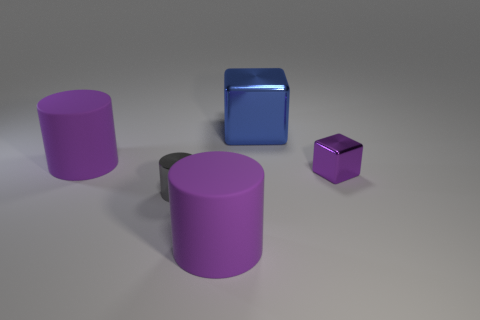Can you estimate the sizes of the objects relative to each other? Starting with the largest object, the tall aubergine cylinder might be roughly twice the height of the medium-sized blue cube, which in turn is larger than the small purple reflective cube. The shorter aubergine cylinder is similar in height to the medium-sized blue cube but differs in shape. 